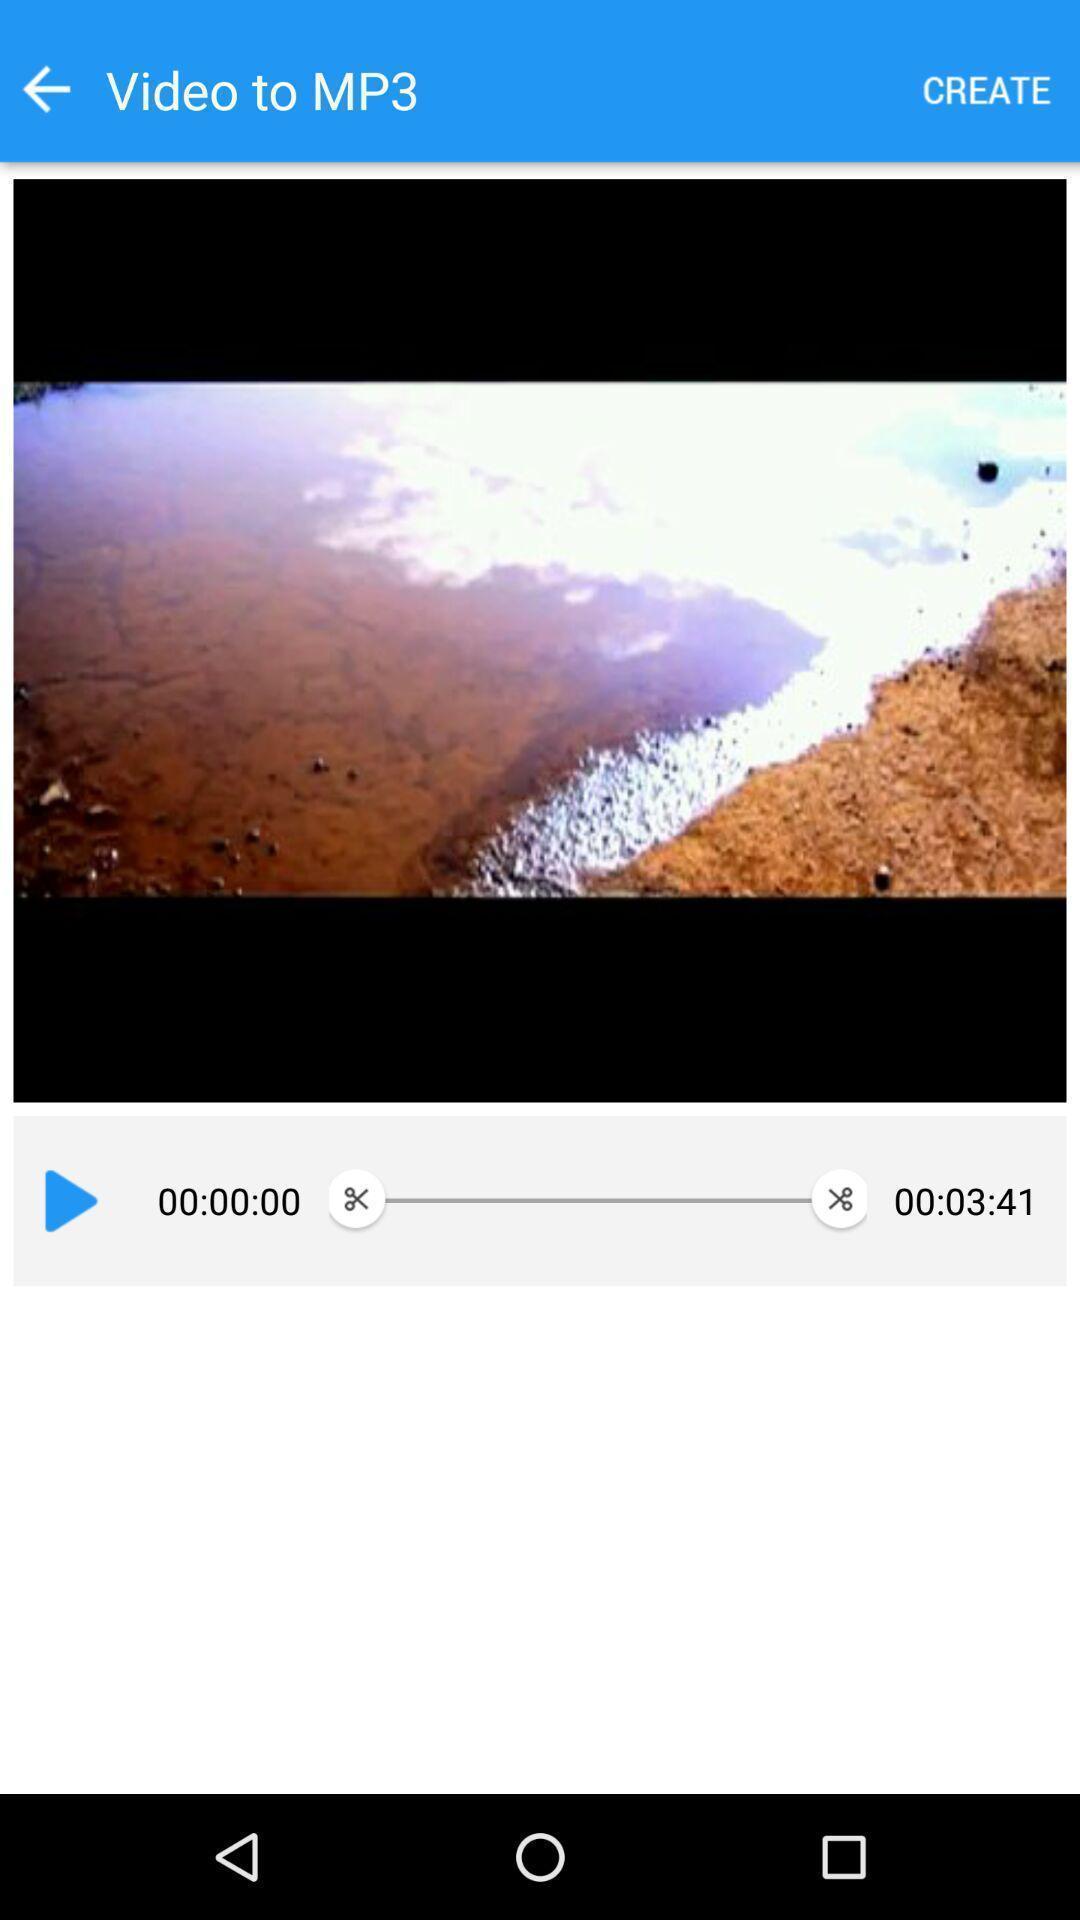Describe the visual elements of this screenshot. Screen displaying video with its duration. 